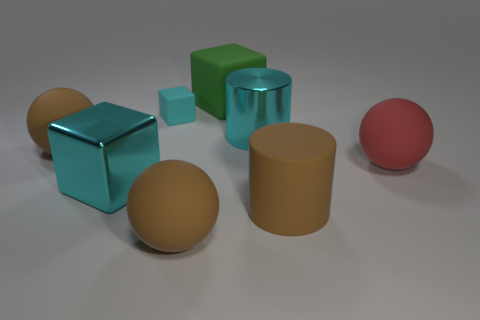Do the small block and the shiny cylinder have the same color?
Provide a short and direct response. Yes. Is there anything else that is the same size as the cyan matte cube?
Provide a succinct answer. No. Is the number of things to the left of the brown cylinder less than the number of things in front of the green object?
Offer a terse response. Yes. There is a big brown rubber cylinder; how many cyan metallic things are in front of it?
Provide a short and direct response. 0. Are there any small gray cylinders made of the same material as the large cyan block?
Your answer should be very brief. No. Is the number of green rubber things in front of the small cyan cube greater than the number of cyan metallic things that are in front of the big brown cylinder?
Make the answer very short. No. The cyan matte block has what size?
Your answer should be compact. Small. What is the shape of the green rubber object behind the big red rubber thing?
Make the answer very short. Cube. Does the tiny matte thing have the same shape as the large green object?
Your answer should be compact. Yes. Are there the same number of brown rubber spheres that are on the right side of the small cyan object and tiny blocks?
Your response must be concise. Yes. 